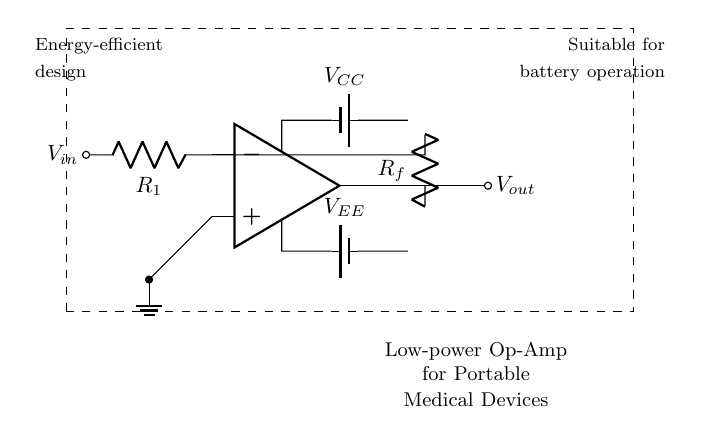What is the type of the main component in this circuit? The main component is an operational amplifier, as indicated in the diagram where the op amp symbol is prominently featured.
Answer: operational amplifier What does the component labeled R1 represent? R1 is the input resistor in the circuit, which controls the current flowing into the inverting terminal of the operational amplifier as shown by its connection to Vin.
Answer: input resistor How are the power supply voltages labeled in the circuit? The circuit uses two power supply voltages labeled VCC for the positive supply and VEE for the negative supply, which are represented with battery symbols connected to the op amp.
Answer: VCC and VEE What is connected to the non-inverting terminal of the operational amplifier? The non-inverting terminal of the operational amplifier is connected to ground, shown in the circuit with a direct connection to the ground symbol.
Answer: ground Why is this circuit design described as energy-efficient? The circuit is described as energy-efficient because it uses a low-power operational amplifier suitable for battery operation, minimizing energy consumption, which is indicated in the accompanying text description.
Answer: low-power design What type of application is suitable for this circuit? This circuit is suitable for portable medical devices, indicated by the descriptive text at the bottom of the diagram highlighting its design purpose.
Answer: portable medical devices What does the feedback resistor Rf do in this circuit? The feedback resistor Rf forms a closed-loop gain configuration in the amplifier, influencing the level of output in relation to the input, which is evidenced by its connection from the output back to the inverting terminal.
Answer: feedback resistor 